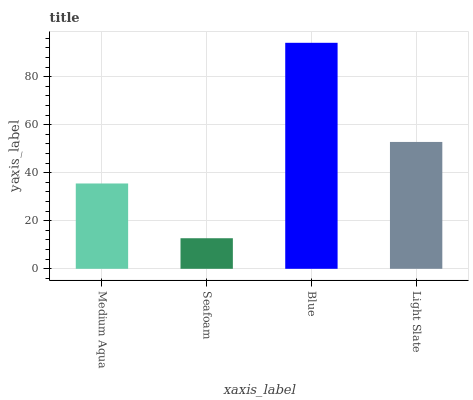Is Blue the minimum?
Answer yes or no. No. Is Seafoam the maximum?
Answer yes or no. No. Is Blue greater than Seafoam?
Answer yes or no. Yes. Is Seafoam less than Blue?
Answer yes or no. Yes. Is Seafoam greater than Blue?
Answer yes or no. No. Is Blue less than Seafoam?
Answer yes or no. No. Is Light Slate the high median?
Answer yes or no. Yes. Is Medium Aqua the low median?
Answer yes or no. Yes. Is Blue the high median?
Answer yes or no. No. Is Light Slate the low median?
Answer yes or no. No. 